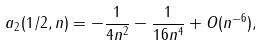Convert formula to latex. <formula><loc_0><loc_0><loc_500><loc_500>a _ { 2 } ( 1 / 2 , n ) = - \frac { 1 } { 4 n ^ { 2 } } - \frac { 1 } { 1 6 n ^ { 4 } } + O ( n ^ { - 6 } ) ,</formula> 